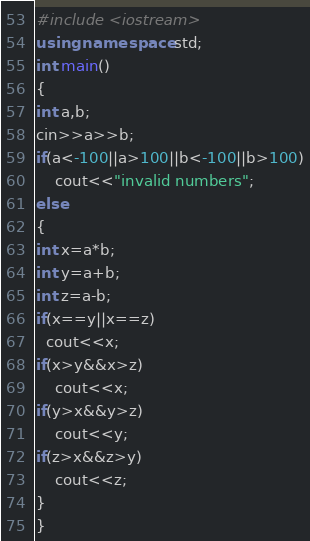<code> <loc_0><loc_0><loc_500><loc_500><_C++_>#include <iostream>
using namespace std;
int main()
{
int a,b;
cin>>a>>b;
if(a<-100||a>100||b<-100||b>100)
    cout<<"invalid numbers";
else
{
int x=a*b;
int y=a+b;
int z=a-b;
if(x==y||x==z)
  cout<<x;
if(x>y&&x>z)
    cout<<x;
if(y>x&&y>z)
    cout<<y;
if(z>x&&z>y)
    cout<<z;
}
}
</code> 